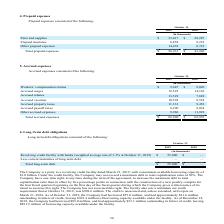From Sanderson Farms's financial document, What is the Workers’ compensation claims for fiscal years 2019 and 2018 respectively? The document shows two values: $9,687 and $9,020 (in thousands). From the document: "Workers’ compensation claims $ 9,687 $ 9,020 Workers’ compensation claims $ 9,687 $ 9,020..." Also, What is the Accrued wages for fiscal years 2019 and 2018 respectively? The document shows two values: 19,525 and 14,142 (in thousands). From the document: "Accrued wages 19,525 14,142 Accrued wages 19,525 14,142..." Also, What does the table provide data about? According to the financial document, Accrued expenses. The relevant text states: "5. Accrued expenses..." Also, can you calculate: What is the average Workers’ compensation claims for fiscal years 2019 and 2018? To answer this question, I need to perform calculations using the financial data. The calculation is: (9,687+ 9,020)/2, which equals 9353.5 (in thousands). This is based on the information: "Workers’ compensation claims $ 9,687 $ 9,020 Workers’ compensation claims $ 9,687 $ 9,020..." The key data points involved are: 9,020, 9,687. Also, can you calculate: What is the average Accrued payroll taxes for fiscal years 2019 and 2018? To answer this question, I need to perform calculations using the financial data. The calculation is: (8,290+ 9,034)/2, which equals 8662 (in thousands). This is based on the information: "Accrued payroll taxes 8,290 9,034 Accrued payroll taxes 8,290 9,034..." The key data points involved are: 8,290, 9,034. Also, can you calculate: What is the change in Total accrued expenses between fiscal years 2019 and 2018? Based on the calculation: 82,940-69,953, the result is 12987 (in thousands). This is based on the information: "Total accrued expenses $ 82,940 $ 69,953 Total accrued expenses $ 82,940 $ 69,953..." The key data points involved are: 69,953, 82,940. 